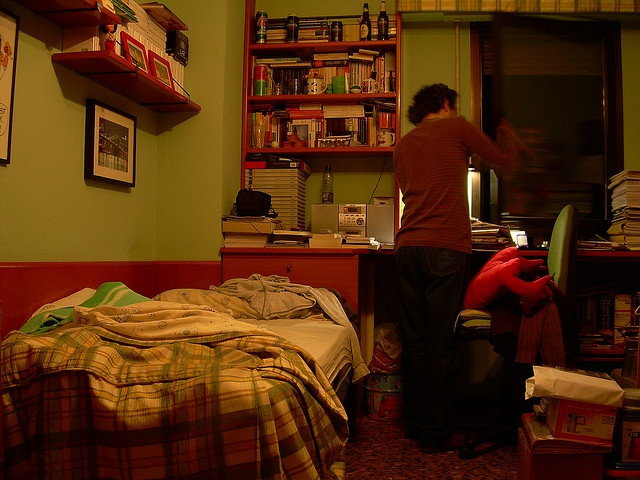Describe the objects in this image and their specific colors. I can see bed in black, olive, and maroon tones, book in black, maroon, and olive tones, people in black, maroon, brown, and olive tones, chair in black, maroon, and olive tones, and book in black, maroon, and olive tones in this image. 